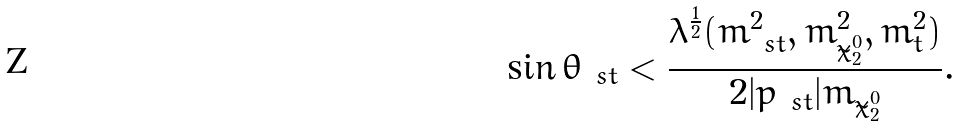Convert formula to latex. <formula><loc_0><loc_0><loc_500><loc_500>\sin \theta _ { \ s t } < \frac { \lambda ^ { \frac { 1 } { 2 } } ( m ^ { 2 } _ { \ s t } , m ^ { 2 } _ { \tilde { \chi } ^ { 0 } _ { 2 } } , m ^ { 2 } _ { t } ) } { 2 | p _ { \ s t } | m _ { \tilde { \chi } ^ { 0 } _ { 2 } } } .</formula> 